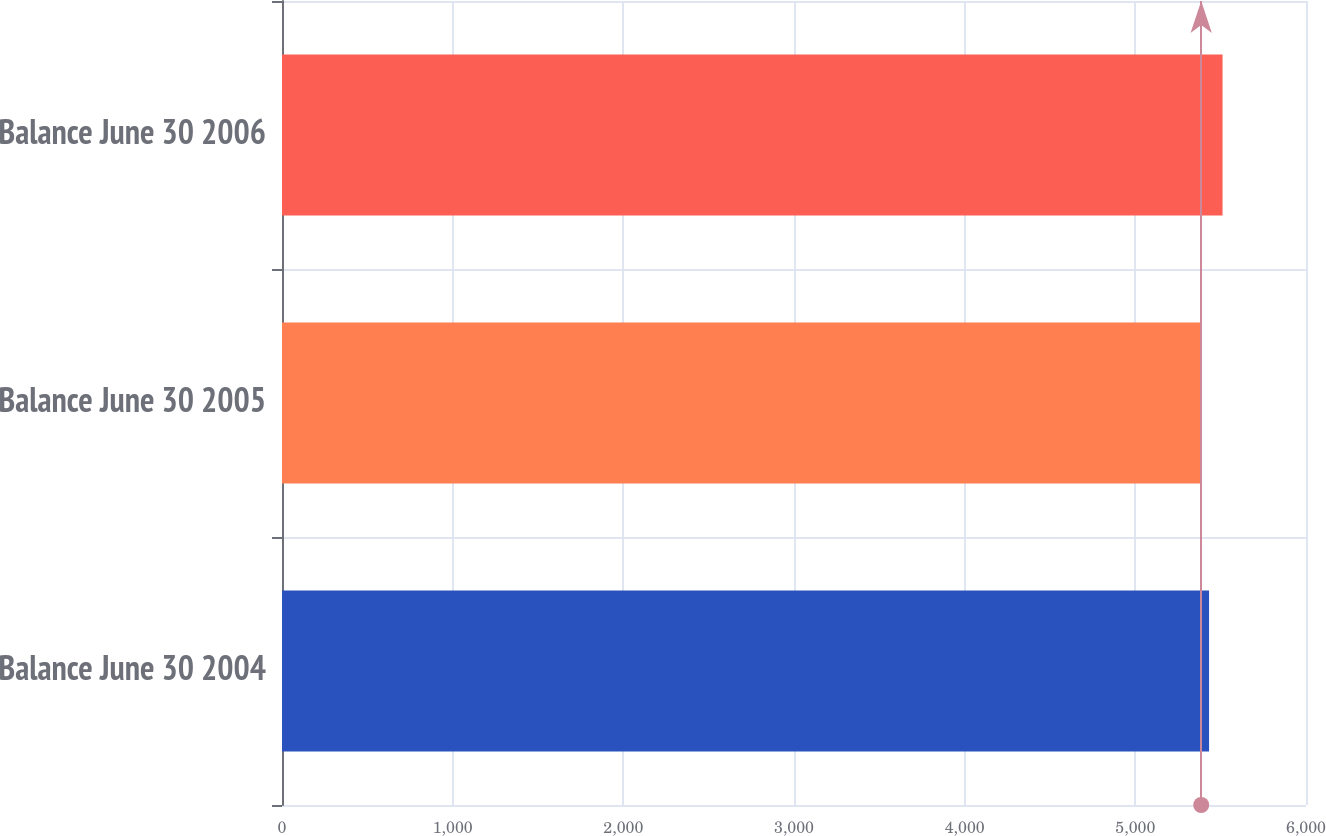<chart> <loc_0><loc_0><loc_500><loc_500><bar_chart><fcel>Balance June 30 2004<fcel>Balance June 30 2005<fcel>Balance June 30 2006<nl><fcel>5432<fcel>5386<fcel>5511<nl></chart> 